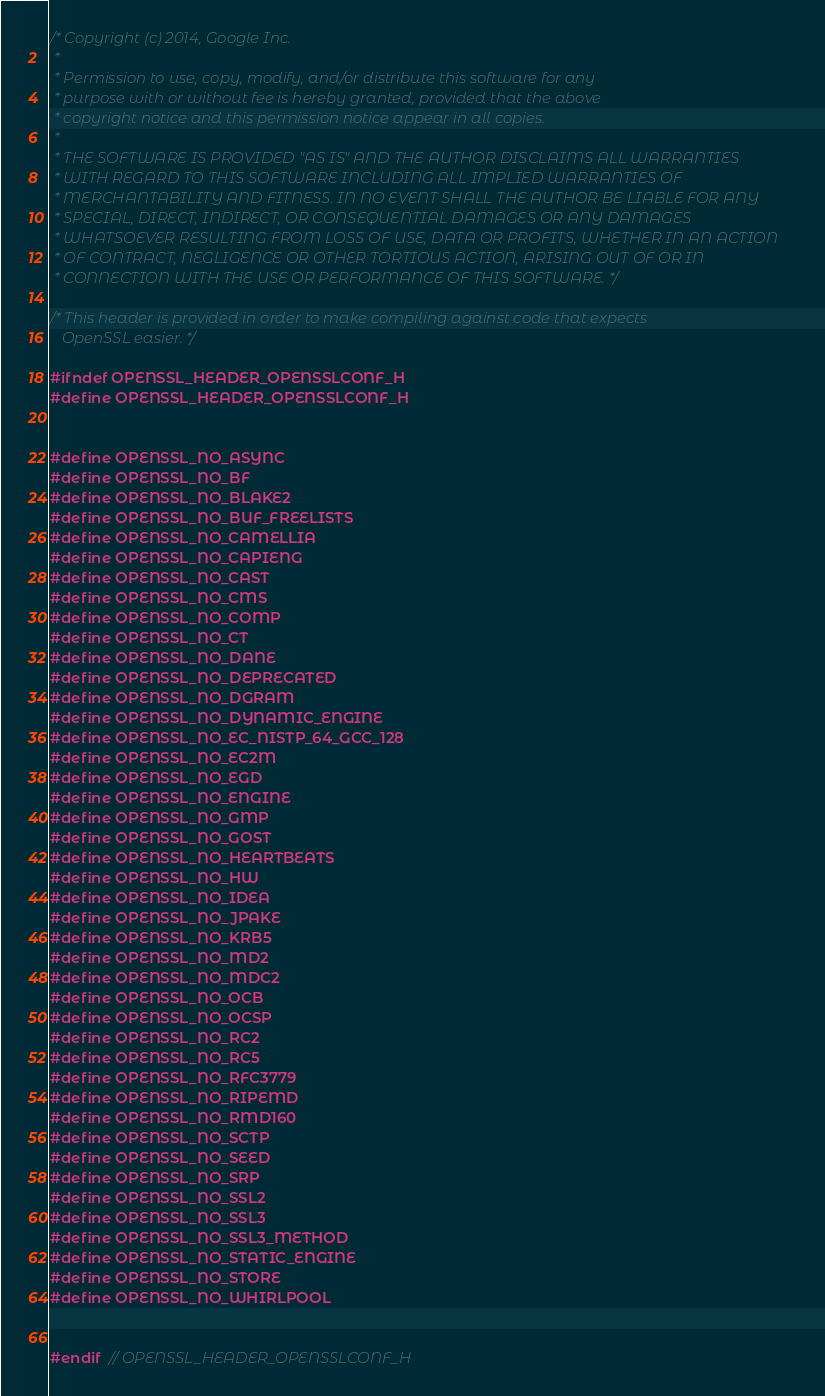<code> <loc_0><loc_0><loc_500><loc_500><_C_>/* Copyright (c) 2014, Google Inc.
 *
 * Permission to use, copy, modify, and/or distribute this software for any
 * purpose with or without fee is hereby granted, provided that the above
 * copyright notice and this permission notice appear in all copies.
 *
 * THE SOFTWARE IS PROVIDED "AS IS" AND THE AUTHOR DISCLAIMS ALL WARRANTIES
 * WITH REGARD TO THIS SOFTWARE INCLUDING ALL IMPLIED WARRANTIES OF
 * MERCHANTABILITY AND FITNESS. IN NO EVENT SHALL THE AUTHOR BE LIABLE FOR ANY
 * SPECIAL, DIRECT, INDIRECT, OR CONSEQUENTIAL DAMAGES OR ANY DAMAGES
 * WHATSOEVER RESULTING FROM LOSS OF USE, DATA OR PROFITS, WHETHER IN AN ACTION
 * OF CONTRACT, NEGLIGENCE OR OTHER TORTIOUS ACTION, ARISING OUT OF OR IN
 * CONNECTION WITH THE USE OR PERFORMANCE OF THIS SOFTWARE. */

/* This header is provided in order to make compiling against code that expects
   OpenSSL easier. */

#ifndef OPENSSL_HEADER_OPENSSLCONF_H
#define OPENSSL_HEADER_OPENSSLCONF_H


#define OPENSSL_NO_ASYNC
#define OPENSSL_NO_BF
#define OPENSSL_NO_BLAKE2
#define OPENSSL_NO_BUF_FREELISTS
#define OPENSSL_NO_CAMELLIA
#define OPENSSL_NO_CAPIENG
#define OPENSSL_NO_CAST
#define OPENSSL_NO_CMS
#define OPENSSL_NO_COMP
#define OPENSSL_NO_CT
#define OPENSSL_NO_DANE
#define OPENSSL_NO_DEPRECATED
#define OPENSSL_NO_DGRAM
#define OPENSSL_NO_DYNAMIC_ENGINE
#define OPENSSL_NO_EC_NISTP_64_GCC_128
#define OPENSSL_NO_EC2M
#define OPENSSL_NO_EGD
#define OPENSSL_NO_ENGINE
#define OPENSSL_NO_GMP
#define OPENSSL_NO_GOST
#define OPENSSL_NO_HEARTBEATS
#define OPENSSL_NO_HW
#define OPENSSL_NO_IDEA
#define OPENSSL_NO_JPAKE
#define OPENSSL_NO_KRB5
#define OPENSSL_NO_MD2
#define OPENSSL_NO_MDC2
#define OPENSSL_NO_OCB
#define OPENSSL_NO_OCSP
#define OPENSSL_NO_RC2
#define OPENSSL_NO_RC5
#define OPENSSL_NO_RFC3779
#define OPENSSL_NO_RIPEMD
#define OPENSSL_NO_RMD160
#define OPENSSL_NO_SCTP
#define OPENSSL_NO_SEED
#define OPENSSL_NO_SRP
#define OPENSSL_NO_SSL2
#define OPENSSL_NO_SSL3
#define OPENSSL_NO_SSL3_METHOD
#define OPENSSL_NO_STATIC_ENGINE
#define OPENSSL_NO_STORE
#define OPENSSL_NO_WHIRLPOOL


#endif  // OPENSSL_HEADER_OPENSSLCONF_H
</code> 